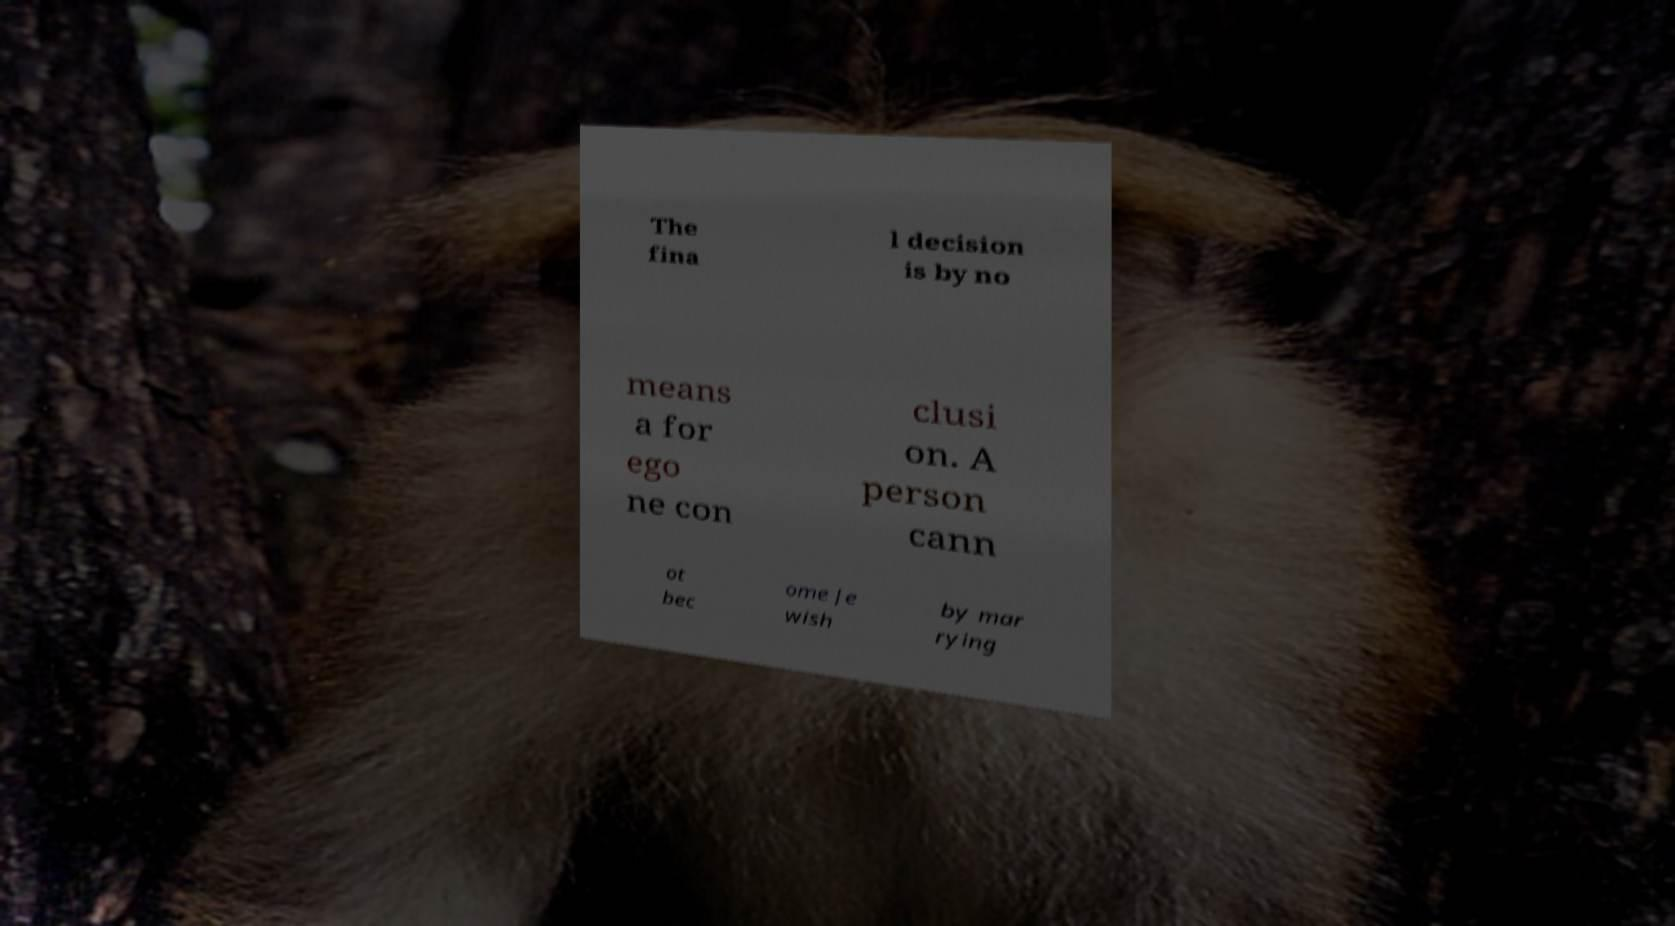Could you extract and type out the text from this image? The fina l decision is by no means a for ego ne con clusi on. A person cann ot bec ome Je wish by mar rying 